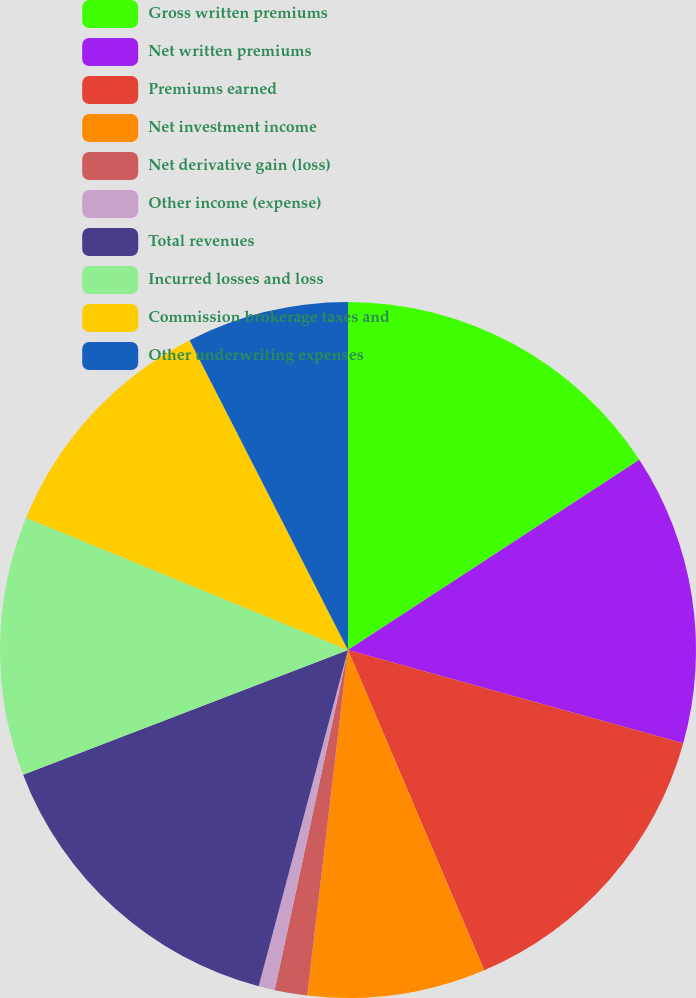Convert chart. <chart><loc_0><loc_0><loc_500><loc_500><pie_chart><fcel>Gross written premiums<fcel>Net written premiums<fcel>Premiums earned<fcel>Net investment income<fcel>Net derivative gain (loss)<fcel>Other income (expense)<fcel>Total revenues<fcel>Incurred losses and loss<fcel>Commission brokerage taxes and<fcel>Other underwriting expenses<nl><fcel>15.79%<fcel>13.53%<fcel>14.28%<fcel>8.27%<fcel>1.51%<fcel>0.75%<fcel>15.04%<fcel>12.03%<fcel>11.28%<fcel>7.52%<nl></chart> 